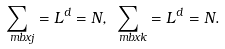Convert formula to latex. <formula><loc_0><loc_0><loc_500><loc_500>\sum _ { \ m b x { j } } = L ^ { d } = N , \sum _ { \ m b x { k } } = L ^ { d } = N .</formula> 